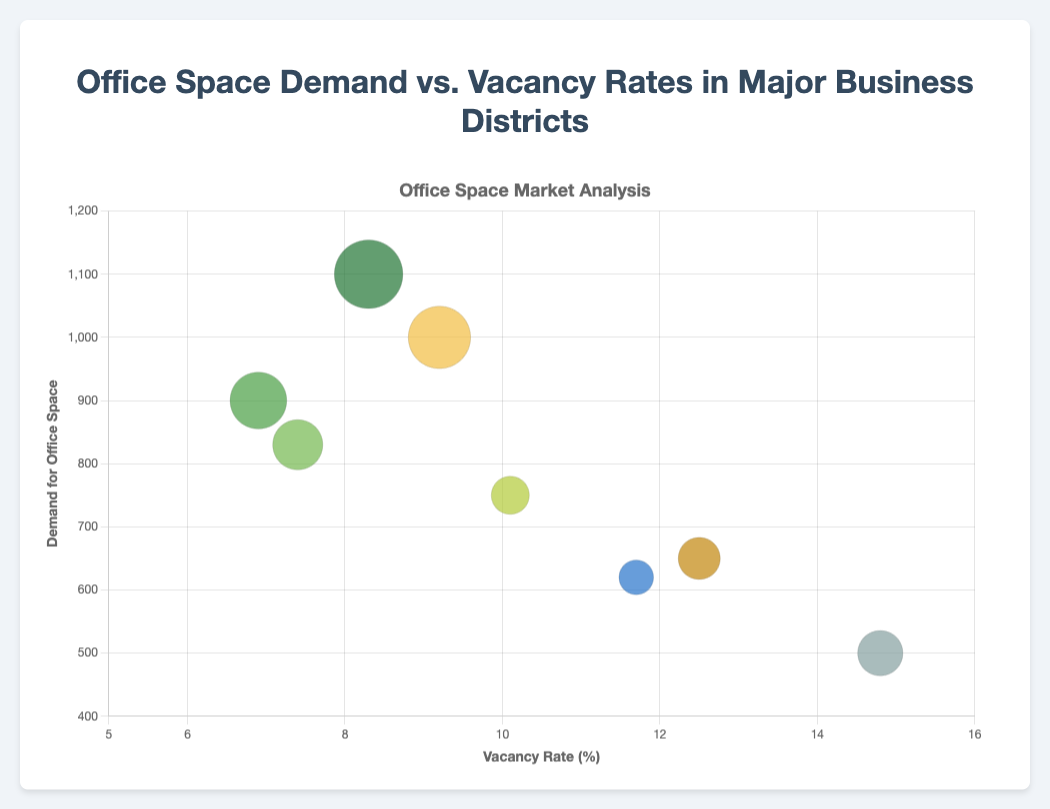What is the title of the chart? The title of the chart is displayed at the top. It reads "Office Space Demand vs. Vacancy Rates in Major Business Districts".
Answer: Office Space Demand vs. Vacancy Rates in Major Business Districts Which business district has the highest demand for office space? By looking at the vertical axis (Demand for Office Space) and identifying the highest point, Midtown Manhattan has the highest demand for office space with a value of 1100.
Answer: Midtown Manhattan What is the relationship between vacancy rates and demand for Silicon Valley? Silicon Valley has a vacancy rate of 6.9% (X-axis) and a demand for office space of 900 (Y-axis).
Answer: Vacancy rate: 6.9%, Demand: 900 How does the average rent per square foot for Boston Financial District compare to that of Houston Downtown? Calculate the average rent per square foot for both districts from the tooltip information. Boston Financial District has an average rent of $50.1/sq ft, while Houston Downtown has $34.6/sq ft.
Answer: Boston Financial District: $50.1/sq ft, Houston Downtown: $34.6/sq ft Which business district has the largest bubble size and what does it represent? The largest bubble size represents a higher average rent per square foot. Midtown Manhattan with $68.5/sq ft has the largest bubble.
Answer: Midtown Manhattan What is the general trend between vacancy rate and demand for office space? Observe the general spread of bubbles. Business districts with lower vacancy rates generally have higher demand for office space.
Answer: Lower vacancy rates, higher demand Which two business districts have the closest vacancy rates but differ significantly in demand? By looking at the X-axis (Vacancy Rate Percent), Chicago Loop (10.1%) and Houston Downtown (11.7%) are close. However, Chicago Loop has a demand of 750 while Houston Downtown has 620.
Answer: Chicago Loop and Houston Downtown What is the approximate average demand for office space across all business districts? Sum the demand for office space (650 + 1100 + 750 + 900 + 500 + 830 + 620 + 1000 = 6350) and divide by the number of districts (8). The average is 6350 / 8 = 793.75.
Answer: 793.75 Which business district appears to be the most balanced in terms of moderate vacancy rate and high demand? By looking at the central distribution, the Boston Financial District has a moderate vacancy rate of 7.4% and a demand of 830, along with a sizeable bubble.
Answer: Boston Financial District 